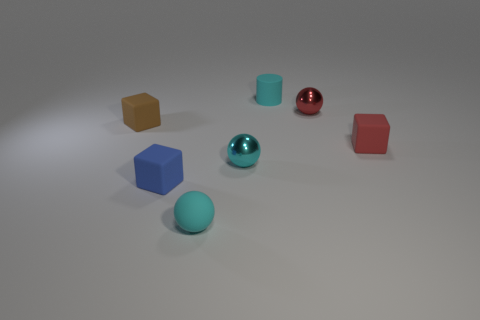What number of rubber things are blue cubes or small cyan balls?
Offer a terse response. 2. Is the number of small cyan things that are in front of the tiny cyan matte cylinder greater than the number of red matte blocks behind the small red block?
Ensure brevity in your answer.  Yes. How many other things are the same size as the cyan metal object?
Offer a very short reply. 6. What is the size of the metal thing that is to the right of the small metallic thing that is in front of the small brown thing?
Make the answer very short. Small. How many small things are either cyan matte cylinders or red metallic spheres?
Keep it short and to the point. 2. There is a metallic ball that is right of the tiny object behind the red thing behind the brown rubber object; how big is it?
Your response must be concise. Small. Is there any other thing that has the same color as the tiny matte cylinder?
Offer a very short reply. Yes. The cube that is behind the small block that is to the right of the tiny cyan rubber object that is to the left of the tiny cyan cylinder is made of what material?
Give a very brief answer. Rubber. Is the shape of the brown matte object the same as the small red metal object?
Your answer should be very brief. No. Are there any other things that are the same material as the tiny red sphere?
Keep it short and to the point. Yes. 